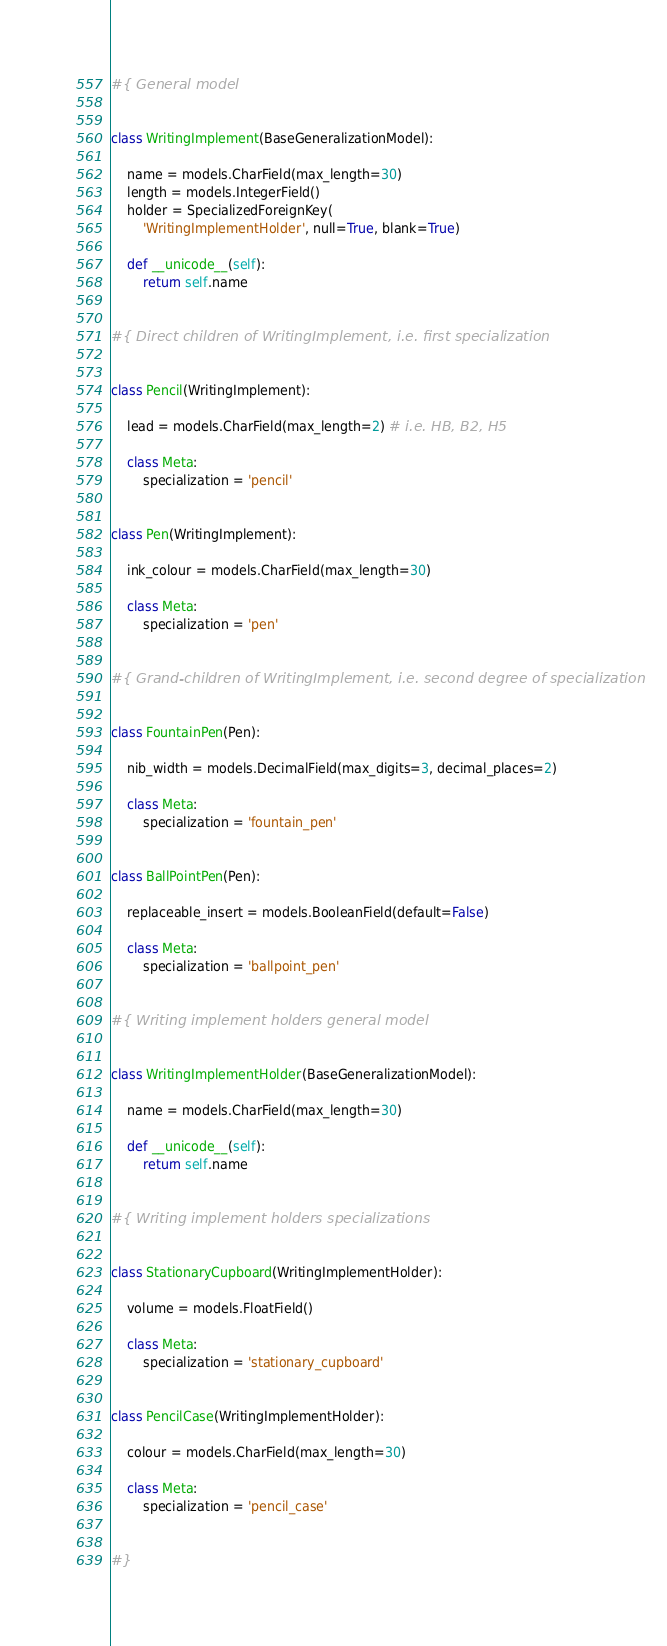<code> <loc_0><loc_0><loc_500><loc_500><_Python_>#{ General model


class WritingImplement(BaseGeneralizationModel):

    name = models.CharField(max_length=30)
    length = models.IntegerField()
    holder = SpecializedForeignKey(
        'WritingImplementHolder', null=True, blank=True)

    def __unicode__(self):
        return self.name


#{ Direct children of WritingImplement, i.e. first specialization


class Pencil(WritingImplement):

    lead = models.CharField(max_length=2) # i.e. HB, B2, H5

    class Meta:
        specialization = 'pencil'


class Pen(WritingImplement):

    ink_colour = models.CharField(max_length=30)

    class Meta:
        specialization = 'pen'


#{ Grand-children of WritingImplement, i.e. second degree of specialization


class FountainPen(Pen):

    nib_width = models.DecimalField(max_digits=3, decimal_places=2)

    class Meta:
        specialization = 'fountain_pen'


class BallPointPen(Pen):

    replaceable_insert = models.BooleanField(default=False)

    class Meta:
        specialization = 'ballpoint_pen'


#{ Writing implement holders general model


class WritingImplementHolder(BaseGeneralizationModel):

    name = models.CharField(max_length=30)

    def __unicode__(self):
        return self.name


#{ Writing implement holders specializations


class StationaryCupboard(WritingImplementHolder):

    volume = models.FloatField()

    class Meta:
        specialization = 'stationary_cupboard'


class PencilCase(WritingImplementHolder):

    colour = models.CharField(max_length=30)

    class Meta:
        specialization = 'pencil_case'


#}
</code> 